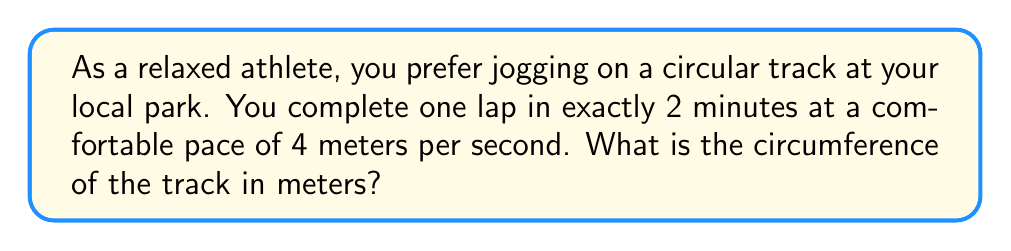Show me your answer to this math problem. Let's approach this step-by-step:

1) First, we need to determine the distance covered in 2 minutes:
   * Time = 2 minutes = 120 seconds
   * Speed = 4 meters per second
   * Distance = Speed × Time
   * Distance = $4 \text{ m/s} \times 120 \text{ s} = 480 \text{ m}$

2) The distance covered in one lap is equal to the circumference of the track.

3) Therefore, the circumference of the track is 480 meters.

4) We can verify this using the formula for circumference:
   $C = 2\pi r$, where $C$ is circumference and $r$ is radius.

5) If we wanted to find the radius, we could use:
   $r = \frac{C}{2\pi} = \frac{480}{2\pi} \approx 76.39 \text{ m}$

This radius seems reasonable for a park running track, confirming our calculation.
Answer: 480 meters 